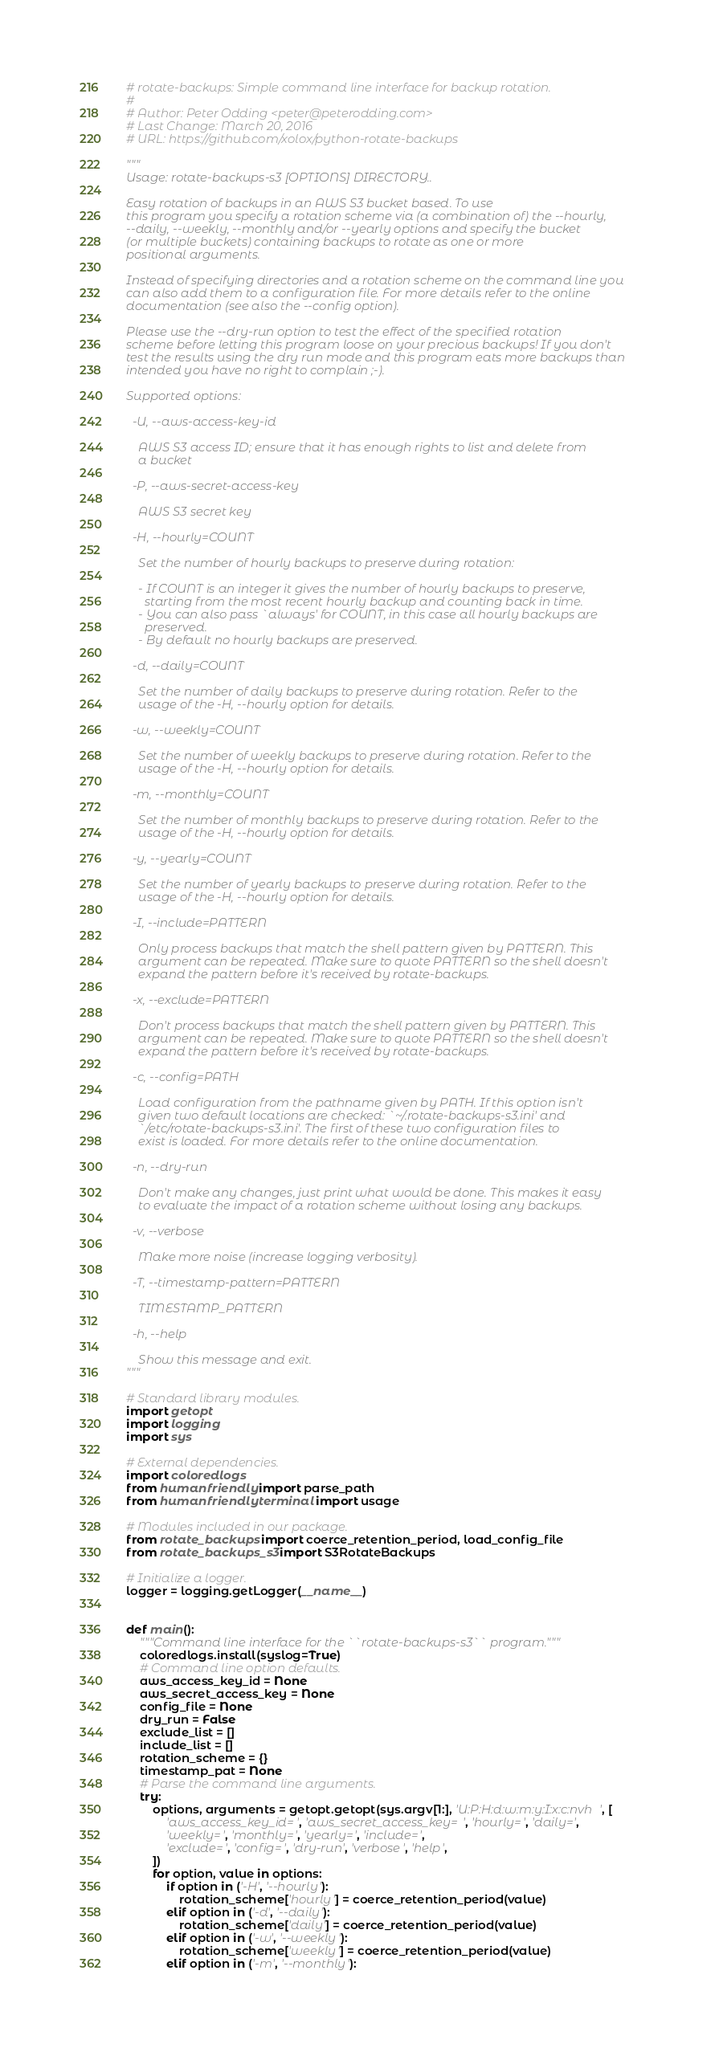Convert code to text. <code><loc_0><loc_0><loc_500><loc_500><_Python_># rotate-backups: Simple command line interface for backup rotation.
#
# Author: Peter Odding <peter@peterodding.com>
# Last Change: March 20, 2016
# URL: https://github.com/xolox/python-rotate-backups

"""
Usage: rotate-backups-s3 [OPTIONS] DIRECTORY..

Easy rotation of backups in an AWS S3 bucket based. To use
this program you specify a rotation scheme via (a combination of) the --hourly,
--daily, --weekly, --monthly and/or --yearly options and specify the bucket
(or multiple buckets) containing backups to rotate as one or more
positional arguments.

Instead of specifying directories and a rotation scheme on the command line you
can also add them to a configuration file. For more details refer to the online
documentation (see also the --config option).

Please use the --dry-run option to test the effect of the specified rotation
scheme before letting this program loose on your precious backups! If you don't
test the results using the dry run mode and this program eats more backups than
intended you have no right to complain ;-).

Supported options:

  -U, --aws-access-key-id
    
    AWS S3 access ID; ensure that it has enough rights to list and delete from
    a bucket

  -P, --aws-secret-access-key
    
    AWS S3 secret key

  -H, --hourly=COUNT

    Set the number of hourly backups to preserve during rotation:

    - If COUNT is an integer it gives the number of hourly backups to preserve,
      starting from the most recent hourly backup and counting back in time.
    - You can also pass `always' for COUNT, in this case all hourly backups are
      preserved.
    - By default no hourly backups are preserved.

  -d, --daily=COUNT

    Set the number of daily backups to preserve during rotation. Refer to the
    usage of the -H, --hourly option for details.

  -w, --weekly=COUNT

    Set the number of weekly backups to preserve during rotation. Refer to the
    usage of the -H, --hourly option for details.

  -m, --monthly=COUNT

    Set the number of monthly backups to preserve during rotation. Refer to the
    usage of the -H, --hourly option for details.

  -y, --yearly=COUNT

    Set the number of yearly backups to preserve during rotation. Refer to the
    usage of the -H, --hourly option for details.

  -I, --include=PATTERN

    Only process backups that match the shell pattern given by PATTERN. This
    argument can be repeated. Make sure to quote PATTERN so the shell doesn't
    expand the pattern before it's received by rotate-backups.

  -x, --exclude=PATTERN

    Don't process backups that match the shell pattern given by PATTERN. This
    argument can be repeated. Make sure to quote PATTERN so the shell doesn't
    expand the pattern before it's received by rotate-backups.

  -c, --config=PATH

    Load configuration from the pathname given by PATH. If this option isn't
    given two default locations are checked: `~/.rotate-backups-s3.ini' and
    `/etc/rotate-backups-s3.ini'. The first of these two configuration files to
    exist is loaded. For more details refer to the online documentation.

  -n, --dry-run

    Don't make any changes, just print what would be done. This makes it easy
    to evaluate the impact of a rotation scheme without losing any backups.

  -v, --verbose

    Make more noise (increase logging verbosity).

  -T, --timestamp-pattern=PATTERN

    TIMESTAMP_PATTERN

  -h, --help

    Show this message and exit.
"""

# Standard library modules.
import getopt
import logging
import sys

# External dependencies.
import coloredlogs
from humanfriendly import parse_path
from humanfriendly.terminal import usage

# Modules included in our package.
from rotate_backups import coerce_retention_period, load_config_file
from rotate_backups_s3 import S3RotateBackups

# Initialize a logger.
logger = logging.getLogger(__name__)


def main():
    """Command line interface for the ``rotate-backups-s3`` program."""
    coloredlogs.install(syslog=True)
    # Command line option defaults.
    aws_access_key_id = None
    aws_secret_access_key = None
    config_file = None
    dry_run = False
    exclude_list = []
    include_list = []
    rotation_scheme = {}
    timestamp_pat = None
    # Parse the command line arguments.
    try:
        options, arguments = getopt.getopt(sys.argv[1:], 'U:P:H:d:w:m:y:I:x:c:nvh', [
            'aws_access_key_id=', 'aws_secret_access_key=', 'hourly=', 'daily=',
            'weekly=', 'monthly=', 'yearly=', 'include=',
            'exclude=', 'config=', 'dry-run', 'verbose', 'help',
        ])
        for option, value in options:
            if option in ('-H', '--hourly'):
                rotation_scheme['hourly'] = coerce_retention_period(value)
            elif option in ('-d', '--daily'):
                rotation_scheme['daily'] = coerce_retention_period(value)
            elif option in ('-w', '--weekly'):
                rotation_scheme['weekly'] = coerce_retention_period(value)
            elif option in ('-m', '--monthly'):</code> 